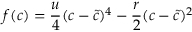<formula> <loc_0><loc_0><loc_500><loc_500>f ( c ) = \frac { u } { 4 } ( c - \tilde { c } ) ^ { 4 } - \frac { r } { 2 } ( c - \tilde { c } ) ^ { 2 }</formula> 